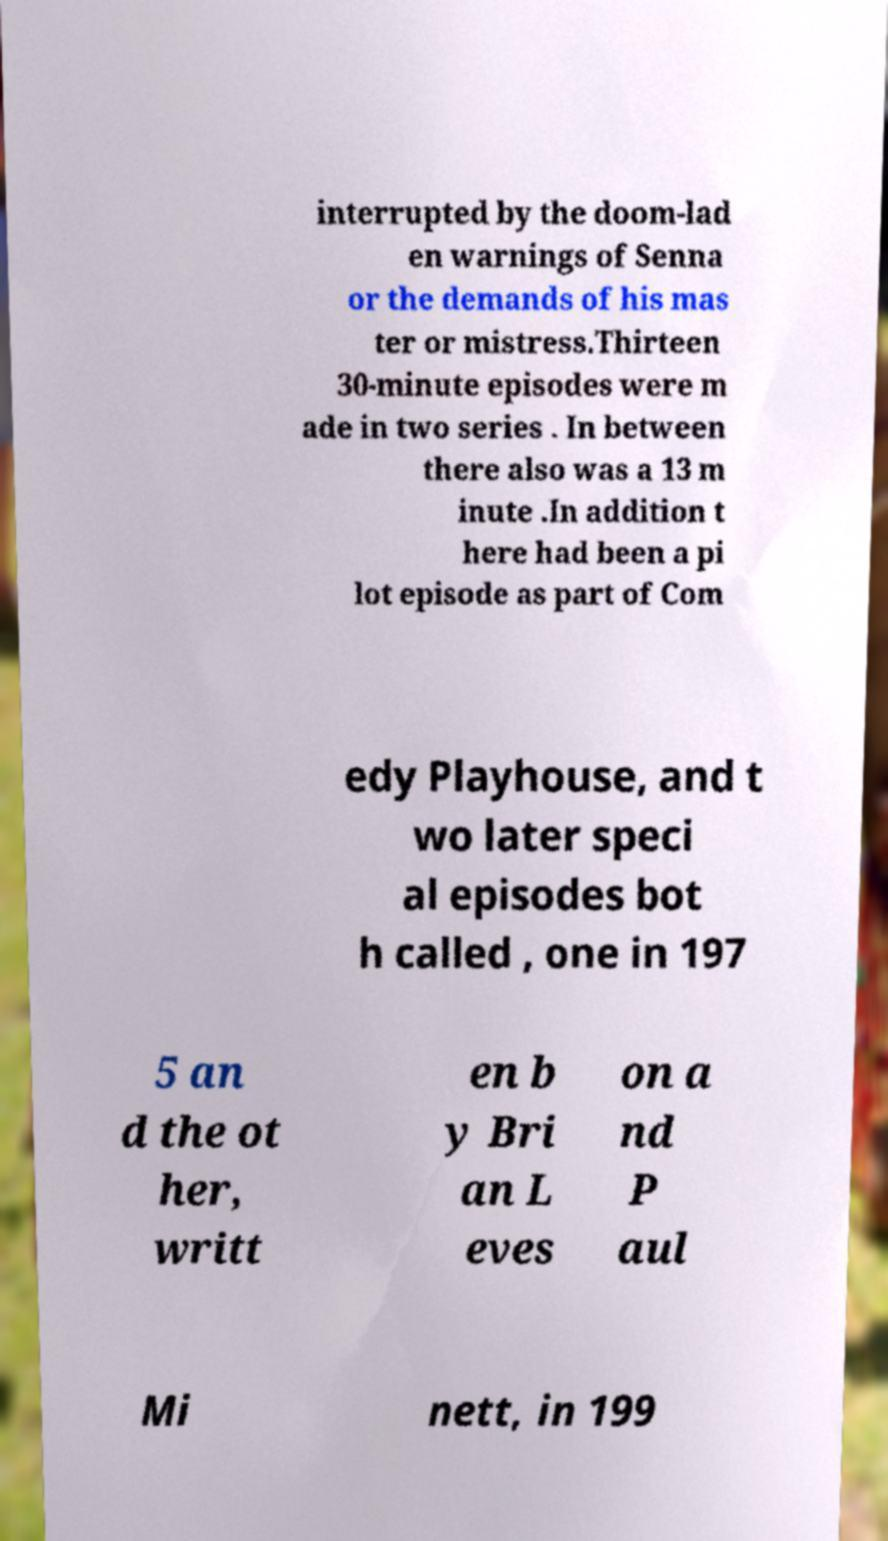Please identify and transcribe the text found in this image. interrupted by the doom-lad en warnings of Senna or the demands of his mas ter or mistress.Thirteen 30-minute episodes were m ade in two series . In between there also was a 13 m inute .In addition t here had been a pi lot episode as part of Com edy Playhouse, and t wo later speci al episodes bot h called , one in 197 5 an d the ot her, writt en b y Bri an L eves on a nd P aul Mi nett, in 199 